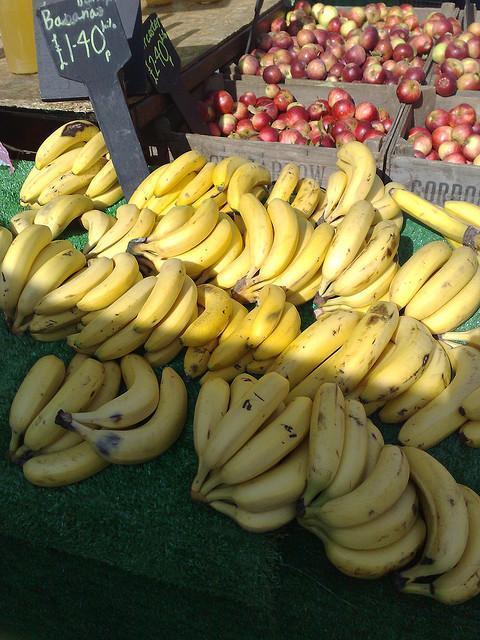How many types of fruit are displayed in the photo?
Give a very brief answer. 2. How many apples are there?
Give a very brief answer. 4. How many bananas are in the photo?
Give a very brief answer. 11. 